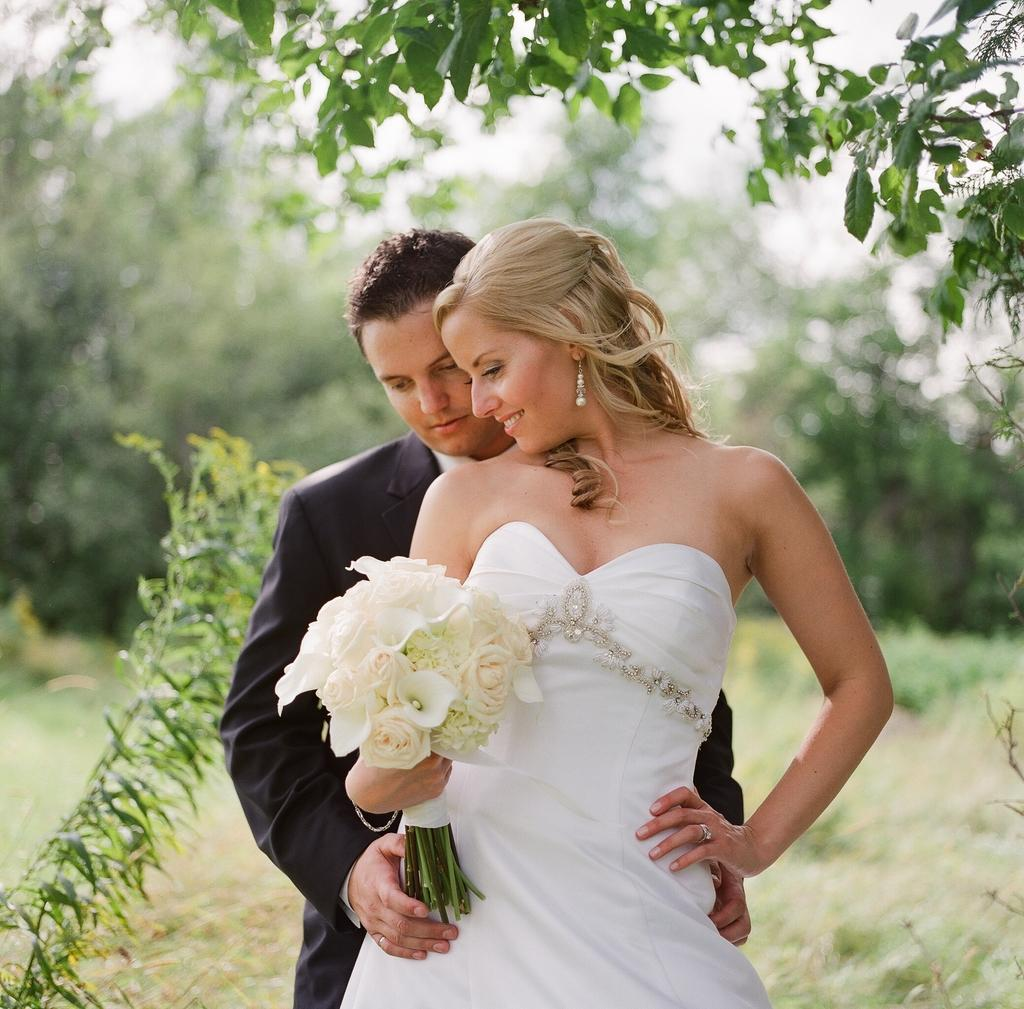Who are the people in the image? There is a man and a lady in the image. What is the lady holding in her hand? The lady is holding flowers in her hand. What can be seen in the background of the image? There are trees in the background of the image. What is visible at the bottom of the image? There is ground visible at the bottom of the image. What type of eyes can be seen on the company logo in the image? There is no company logo present in the image, and therefore no eyes can be seen. 